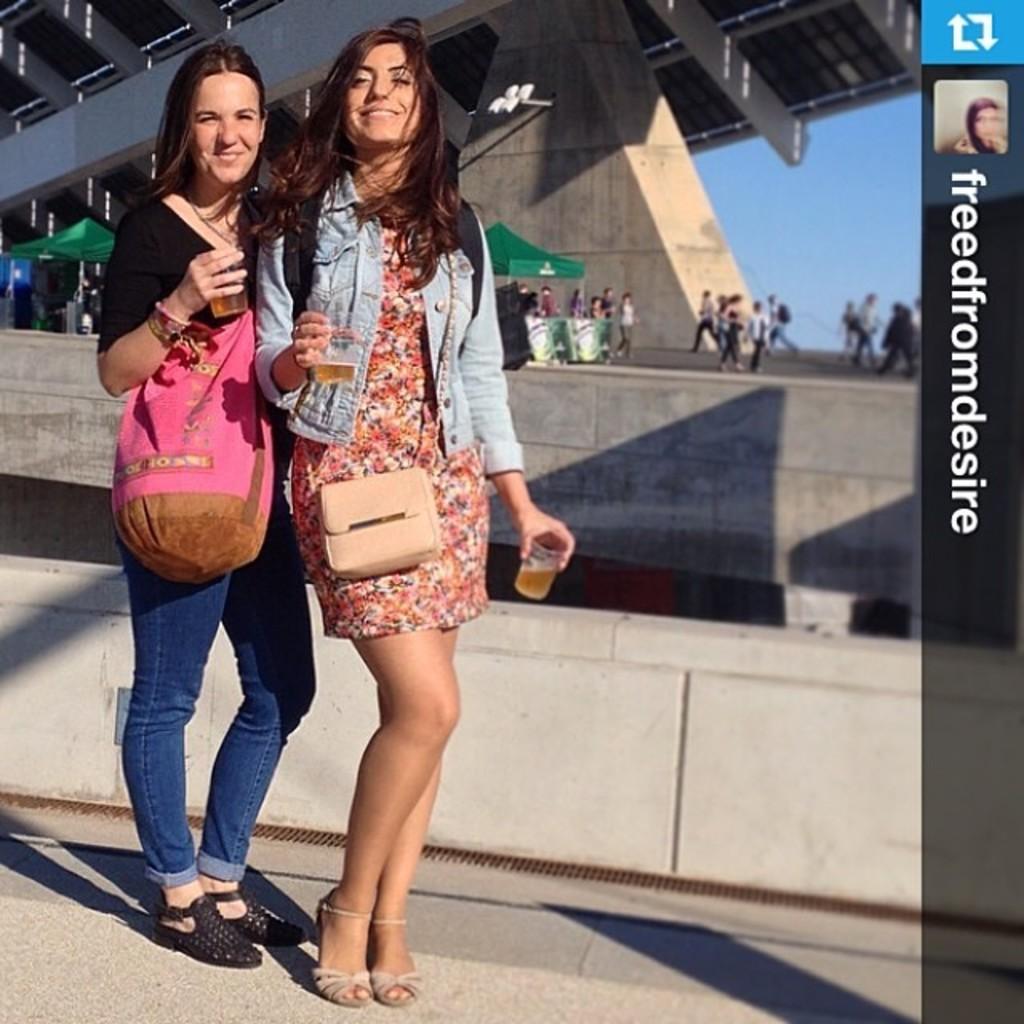Could you give a brief overview of what you see in this image? In this image in the foreground there are two women standing, and they are wearing bags and holding glass. In the glass there is drink, and in the background there are group of people and it looks like a bridge and wall and sky. On the right side there is text, at the bottom there is a walkway. 